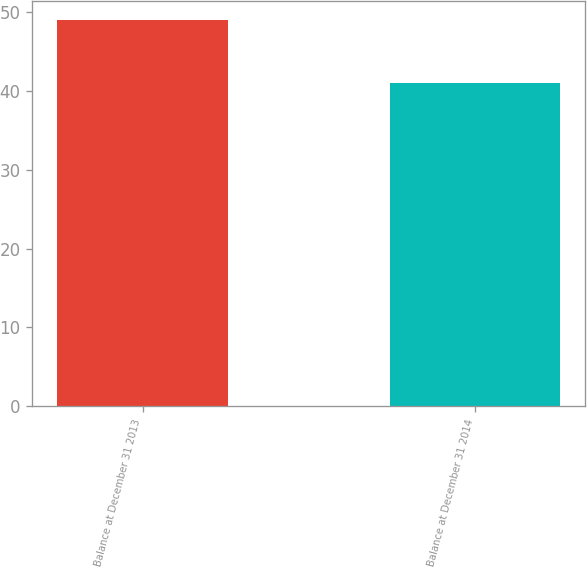Convert chart. <chart><loc_0><loc_0><loc_500><loc_500><bar_chart><fcel>Balance at December 31 2013<fcel>Balance at December 31 2014<nl><fcel>49<fcel>41<nl></chart> 